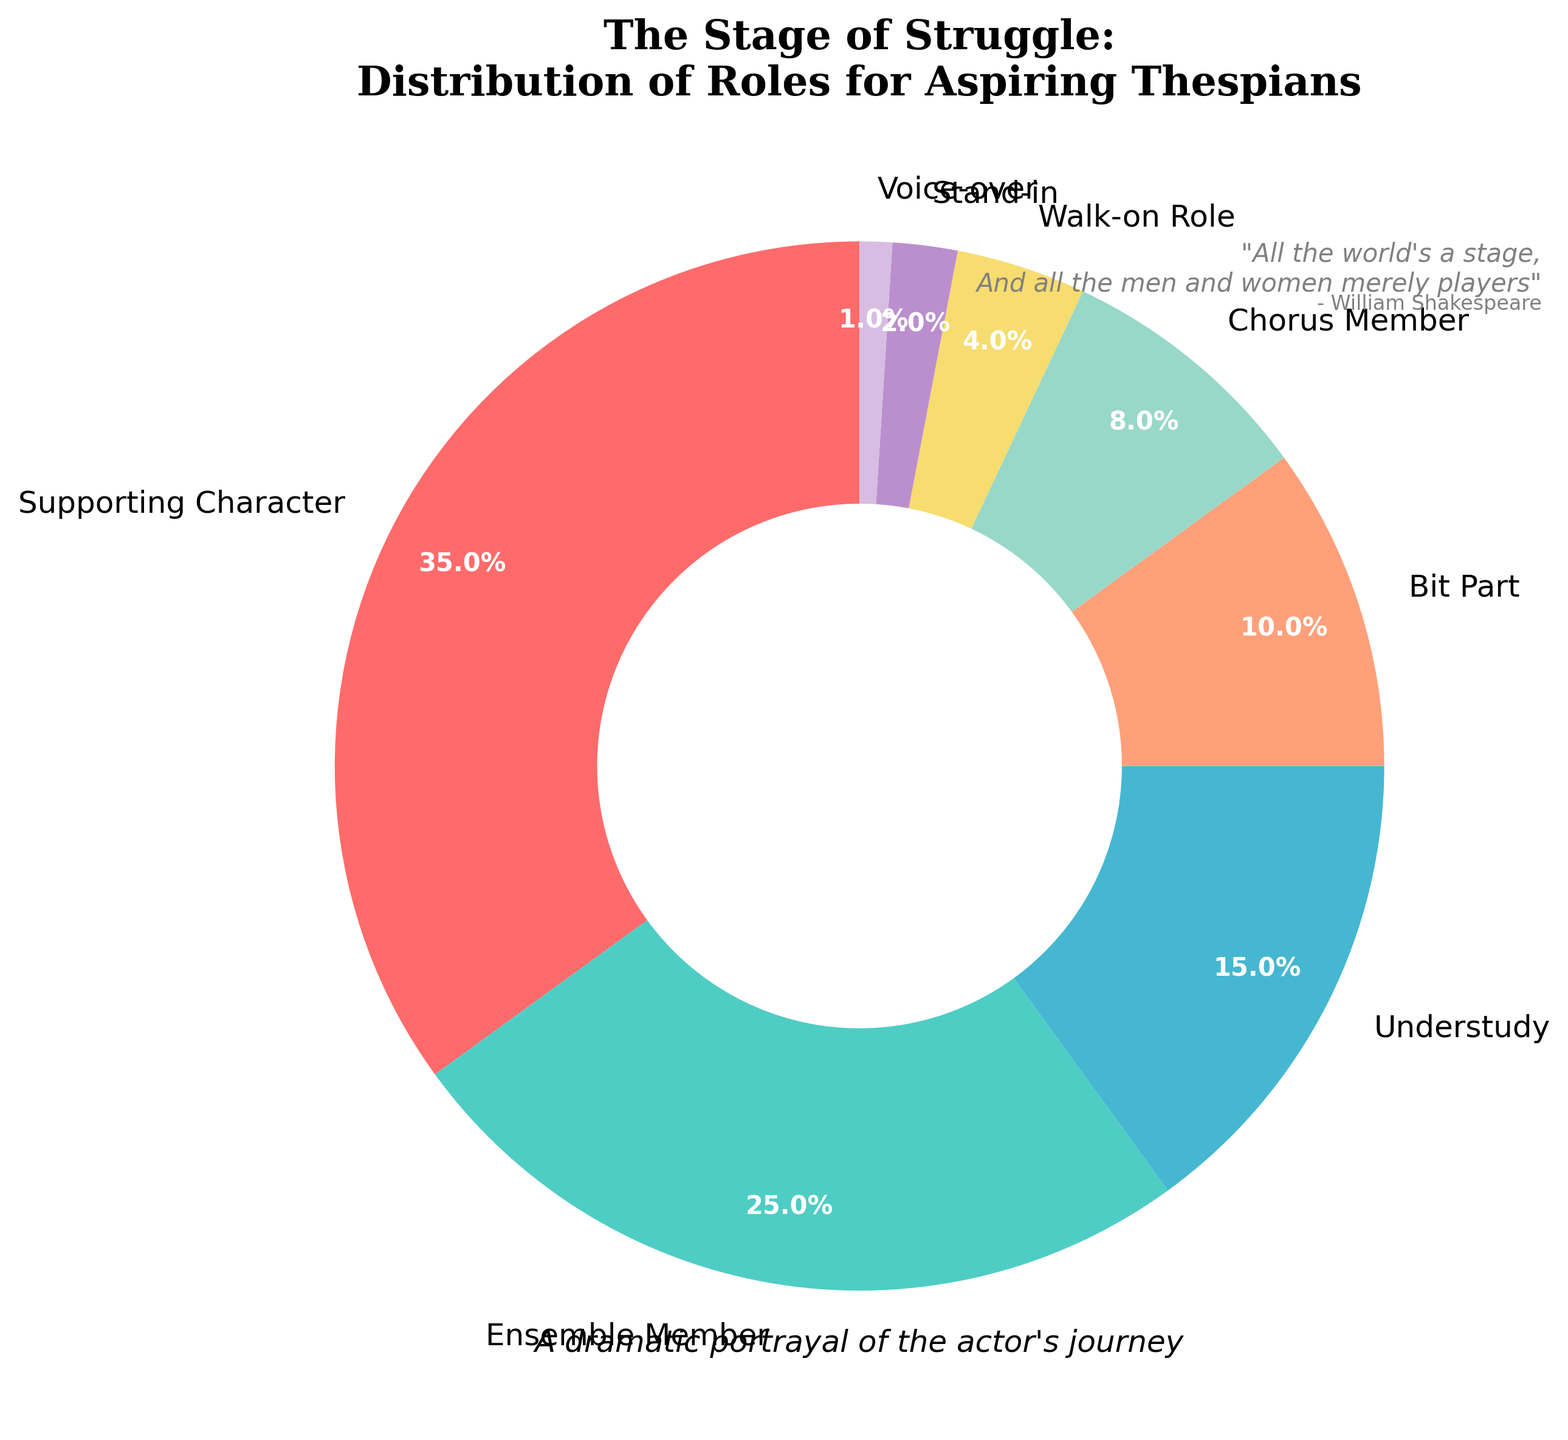What's the most common role played by struggling actors? The largest slice in the pie chart, representing 35%, is labeled as "Supporting Character." Therefore, the most common role is "Supporting Character."
Answer: Supporting Character Which role is played by less than 5% of actors? The slices of the pie chart corresponding to "Walk-on Role," "Stand-in," and "Voice-over" together make up less than 5%. Specifically, "Walk-on Role" is 4%, "Stand-in" is 2%, and "Voice-over" is 1%.
Answer: Walk-on Role, Stand-in, Voice-over How much more common is a Supporting Character role compared to an Ensemble Member role? The Supporting Character role is 35% and the Ensemble Member role is 25%. Subtracting these percentages (35% - 25%), the difference is 10%.
Answer: 10% What proportion of actors play either a Bit Part or a Chorus Member role? The percentages for Bit Part and Chorus Member are 10% and 8%, respectively. Adding these together (10% + 8%), the total proportion is 18%.
Answer: 18% Which role types together make up exactly half of the actors' roles? Looking at the percentages, the Supporting Character (35%) and Ensemble Member (25%) roles together total 60%, which is more than half. For exactly 50%, supporting characters (35%) plus ensemble members (25%) minus chorus members (8%) equals 50%. Thus, Supporting Character and Ensemble Member together make up exactly half.
Answer: Supporting Character and Ensemble Member Is the role of Understudy more common than the role of Bit Part and Walk-on Role combined? The Understudy role is 15%. The Bit Part and Walk-on Role are 10% and 4%, respectively. Adding the latter two (10% + 4%) gives 14%, which is less than 15%.
Answer: Yes Which slice of the pie chart is the smallest and what percentage does it represent? The smallest slice in the pie chart is labeled "Voice-over" and it represents 1%.
Answer: Voice-over, 1% What is the difference in percentage between Chorus Member and Stand-in roles? The percentage for Chorus Member is 8% and for Stand-in is 2%. Subtracting these (8% - 2%), the difference is 6%.
Answer: 6% By how much do the roles of Ensemble Member and Understudy together surpass the roles of Bit Part and Walk-on Role combined? Ensemble Member and Understudy are 25% and 15%, respectively, totaling 40%. Bit Part and Walk-on Role are 10% and 4%, respectively, totaling 14%. The difference (40% - 14%) is 26%.
Answer: 26% What is the sum of the percentages of roles that are 10% or higher? The roles that are 10% or more include Supporting Character (35%), Ensemble Member (25%), Understudy (15%), and Bit Part (10%). Adding these (35% + 25% + 15% + 10%) gives 85%.
Answer: 85% 